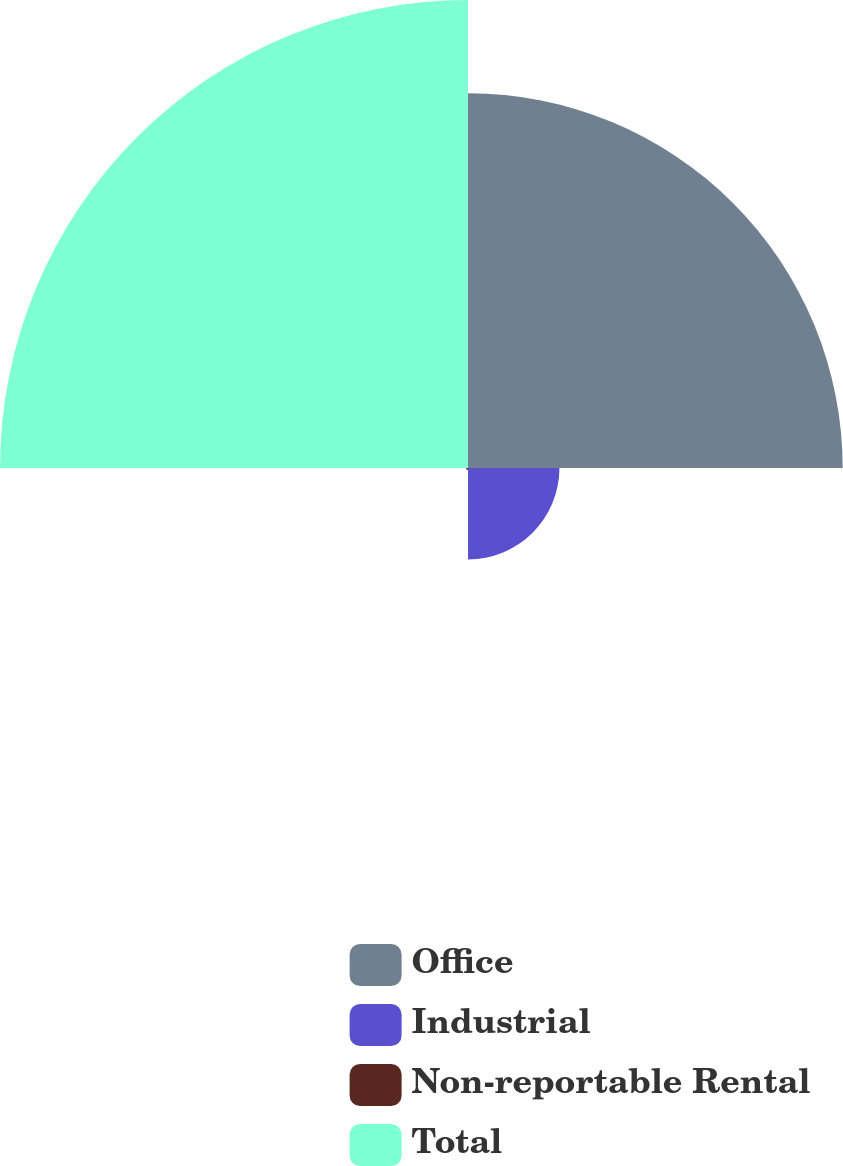Convert chart. <chart><loc_0><loc_0><loc_500><loc_500><pie_chart><fcel>Office<fcel>Industrial<fcel>Non-reportable Rental<fcel>Total<nl><fcel>40.03%<fcel>9.77%<fcel>0.21%<fcel>50.0%<nl></chart> 